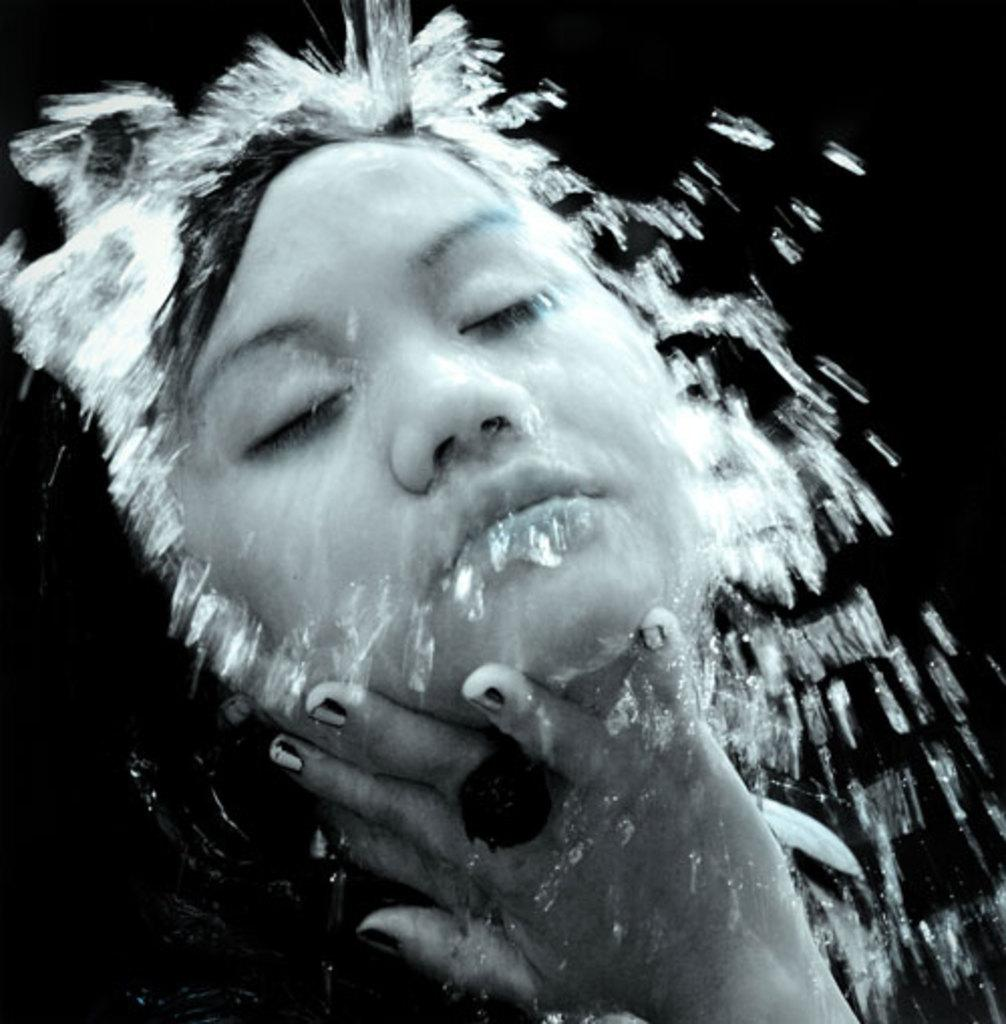What is the main subject of the image? There is a person in the image. What can be seen in the background of the image? The background of the image is dark. What natural element is visible in the image? There is water visible in the image. What type of ring can be seen on the person's finger in the image? There is no ring visible on the person's finger in the image. Where is the park located in the image? There is no park present in the image. 